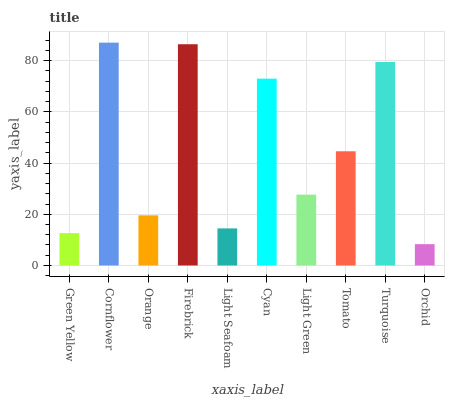Is Orchid the minimum?
Answer yes or no. Yes. Is Cornflower the maximum?
Answer yes or no. Yes. Is Orange the minimum?
Answer yes or no. No. Is Orange the maximum?
Answer yes or no. No. Is Cornflower greater than Orange?
Answer yes or no. Yes. Is Orange less than Cornflower?
Answer yes or no. Yes. Is Orange greater than Cornflower?
Answer yes or no. No. Is Cornflower less than Orange?
Answer yes or no. No. Is Tomato the high median?
Answer yes or no. Yes. Is Light Green the low median?
Answer yes or no. Yes. Is Light Seafoam the high median?
Answer yes or no. No. Is Cornflower the low median?
Answer yes or no. No. 